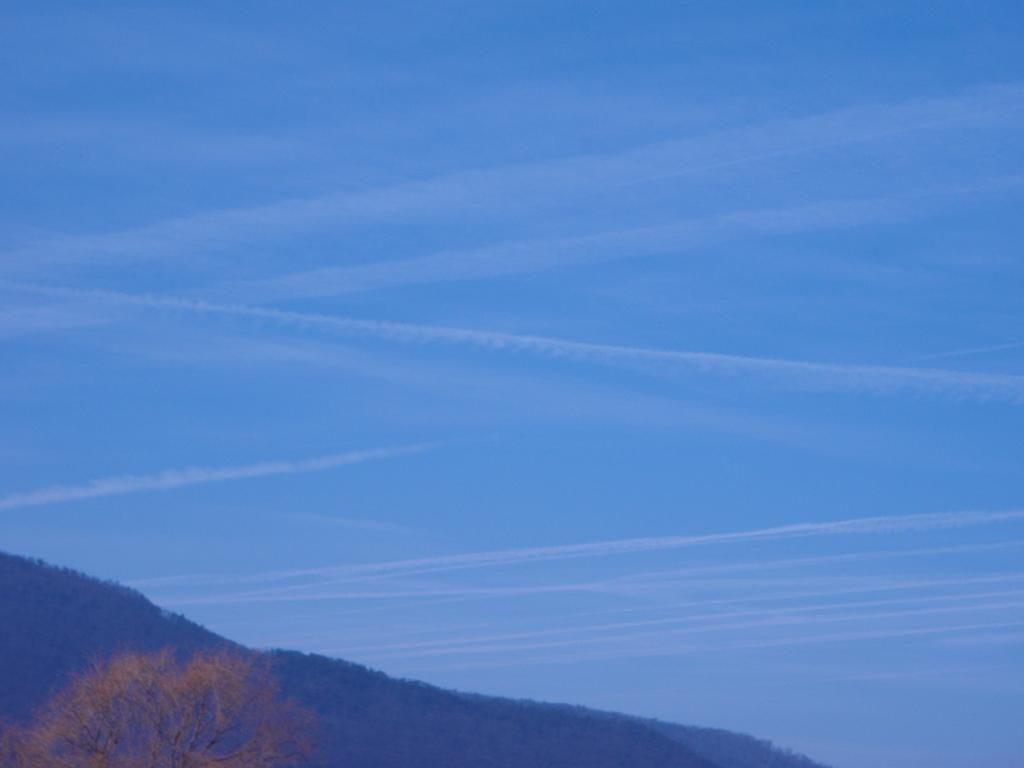What type of natural feature can be seen in the image? There is a tree in the image. What other natural feature is present in the image? There is a mountain in the image. What can be seen in the background of the image? The sky is visible in the background of the image. How many friends are sitting on the mountain in the image? There are no friends present in the image; it only features a tree, a mountain, and the sky. What type of adjustment is being made to the tree in the image? There is no adjustment being made to the tree in the image; it is a static natural feature. 